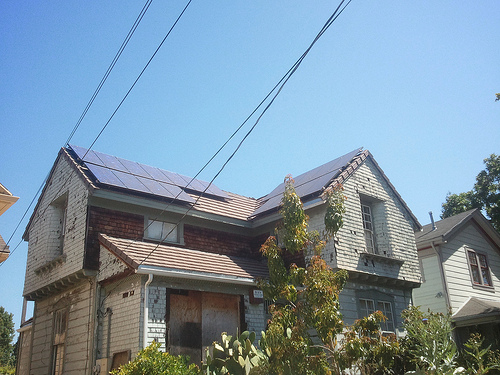<image>
Is the solar panels under the window? No. The solar panels is not positioned under the window. The vertical relationship between these objects is different. 